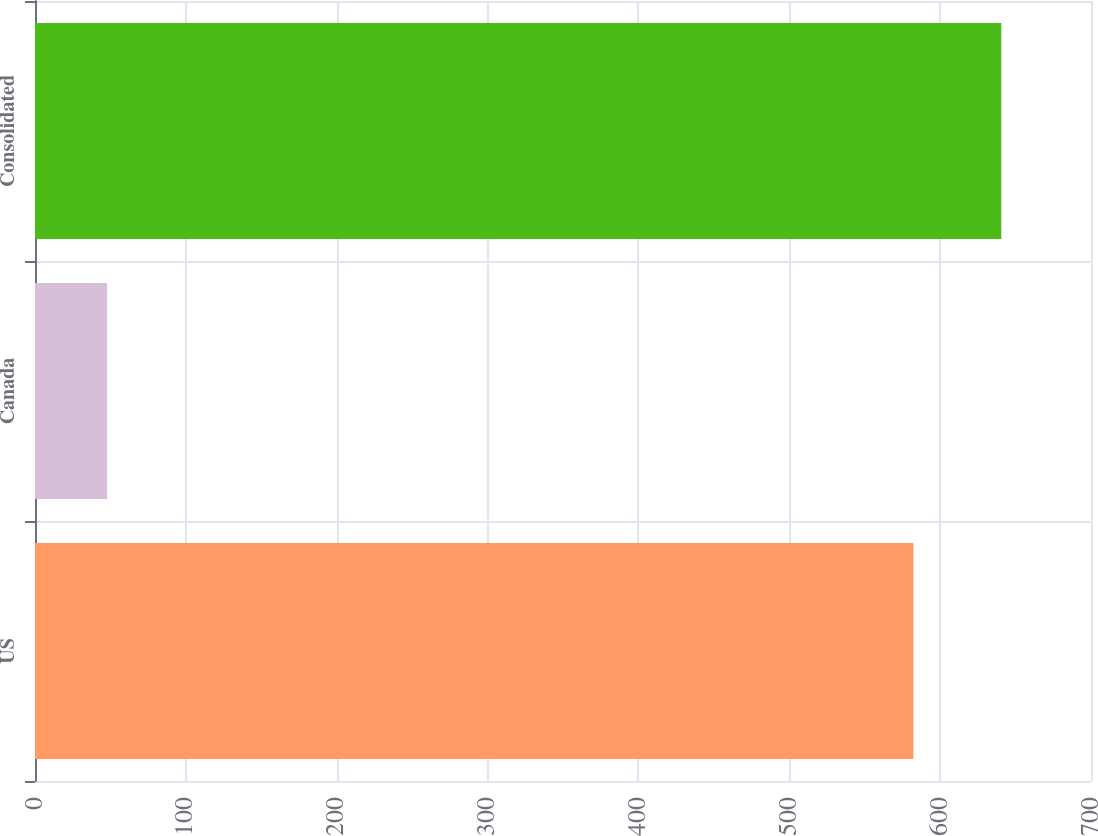Convert chart. <chart><loc_0><loc_0><loc_500><loc_500><bar_chart><fcel>US<fcel>Canada<fcel>Consolidated<nl><fcel>582.3<fcel>47.8<fcel>640.53<nl></chart> 